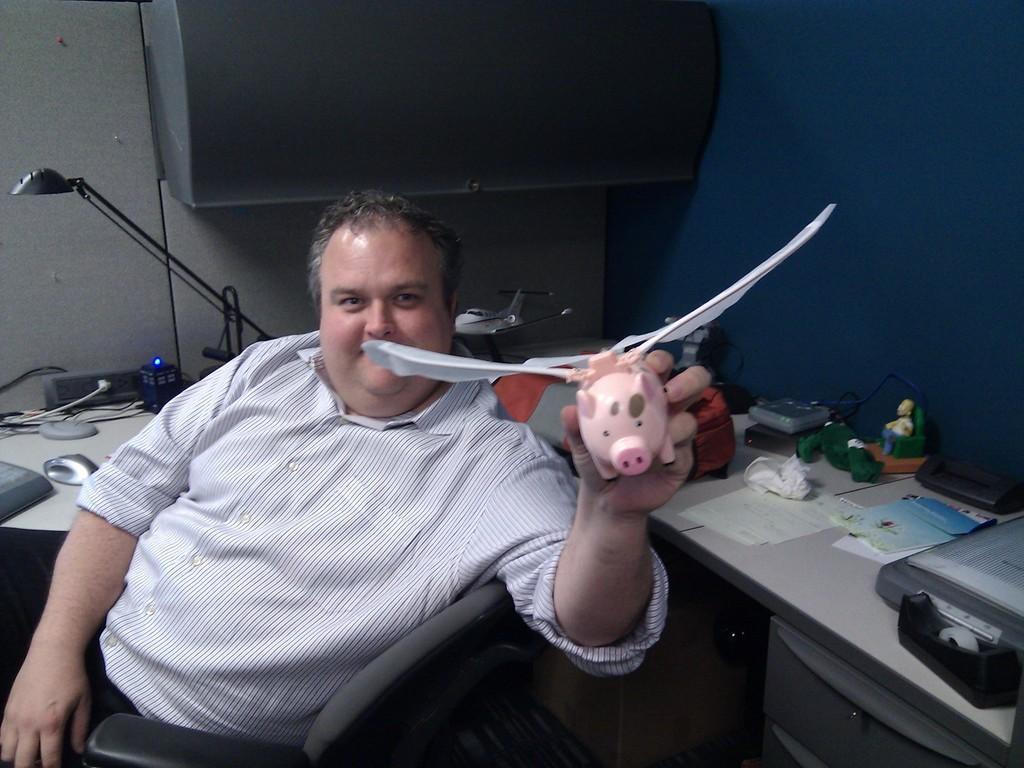Can you describe this image briefly? In this picture there is a man holding a toy. 